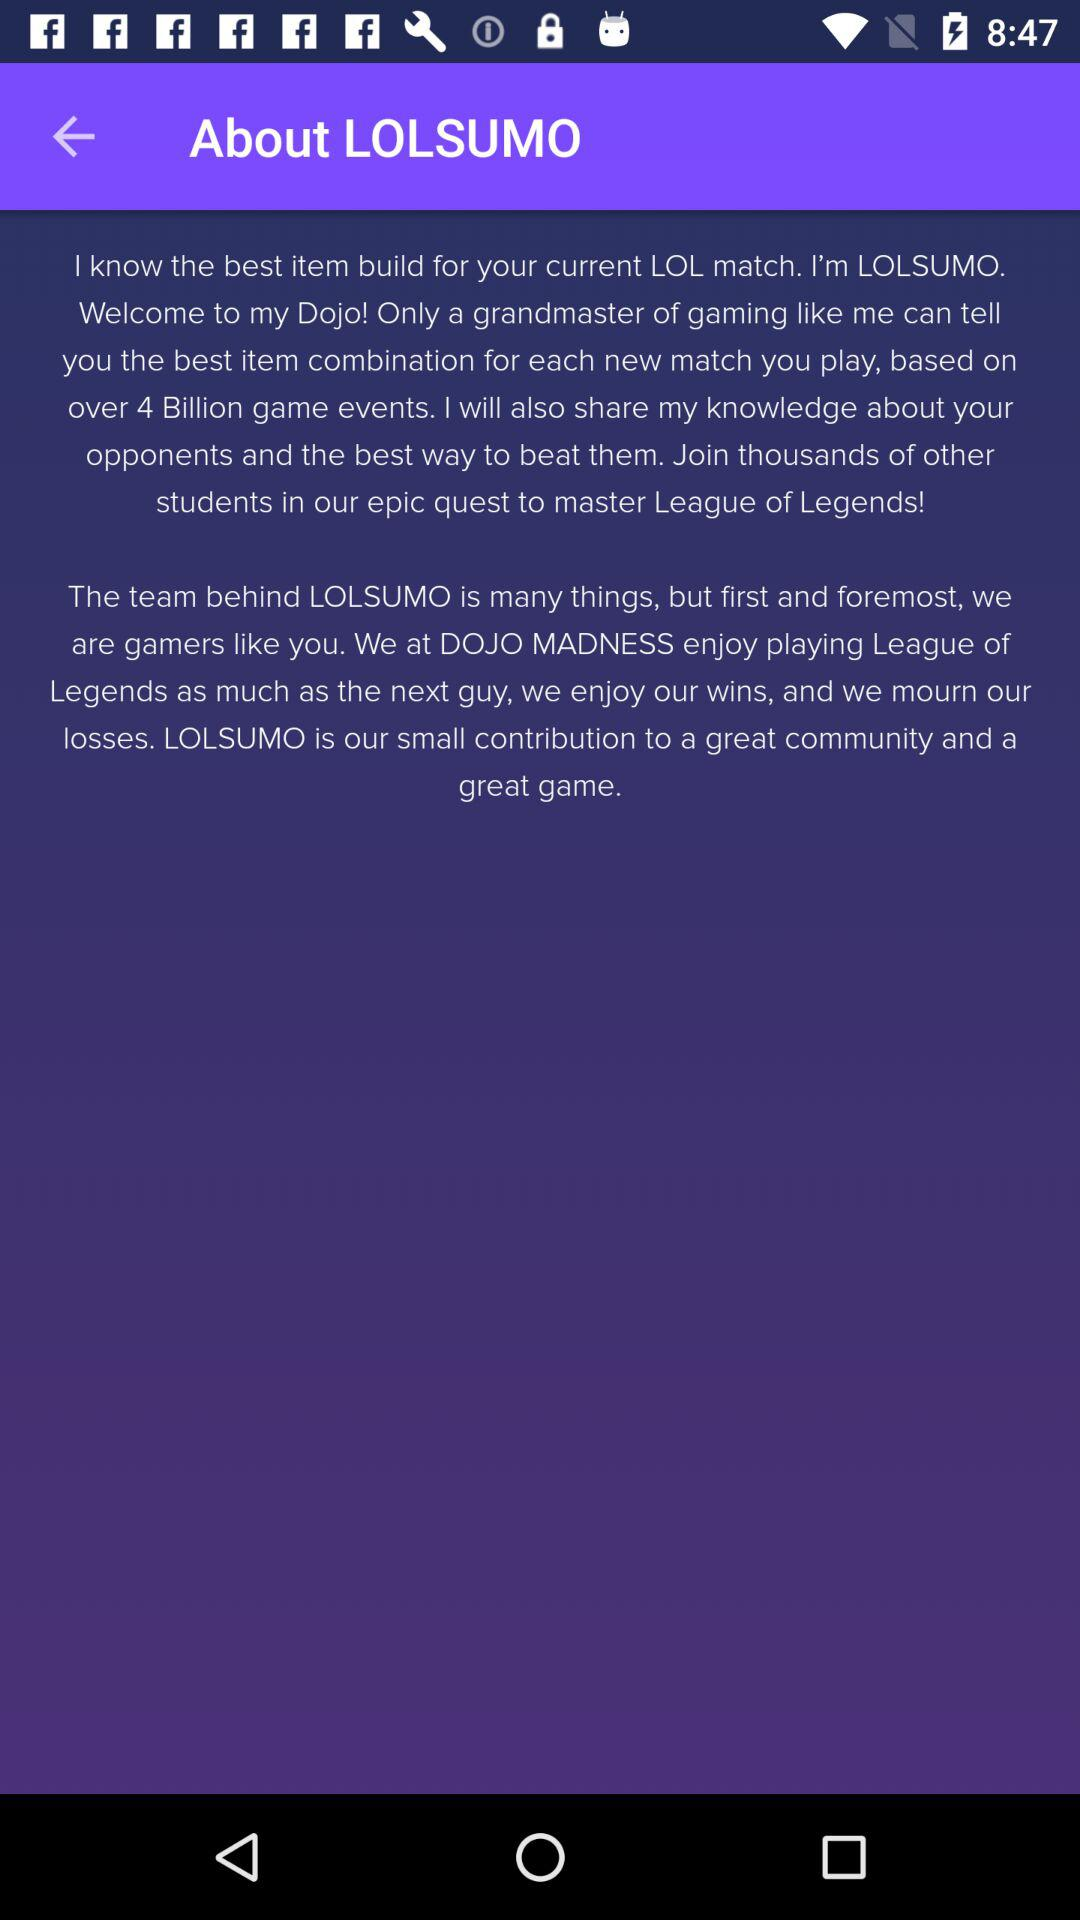What is the Lolsumo?
When the provided information is insufficient, respond with <no answer>. <no answer> 